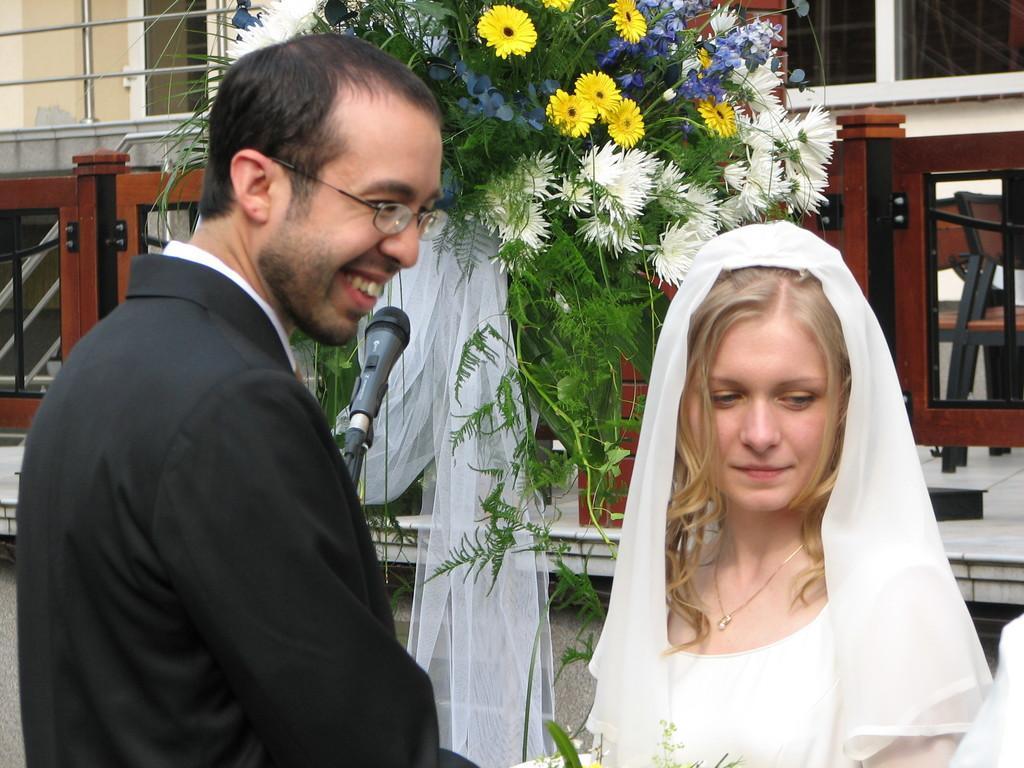Please provide a concise description of this image. In this image I can see a man who is wearing formal dress and side to him I see a woman, who is wearing white color dress and I see that the man is smiling. Behind them I can see a mic and I can see the leaves and the flowers. In the background I can see a building and a white color cloth. 